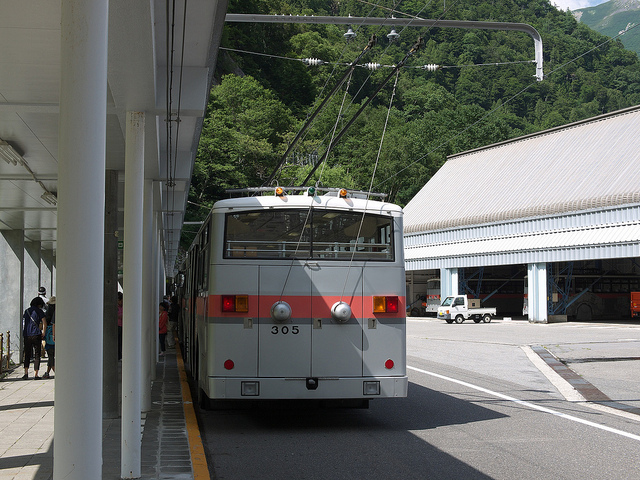Identify and read out the text in this image. 3 0 5 